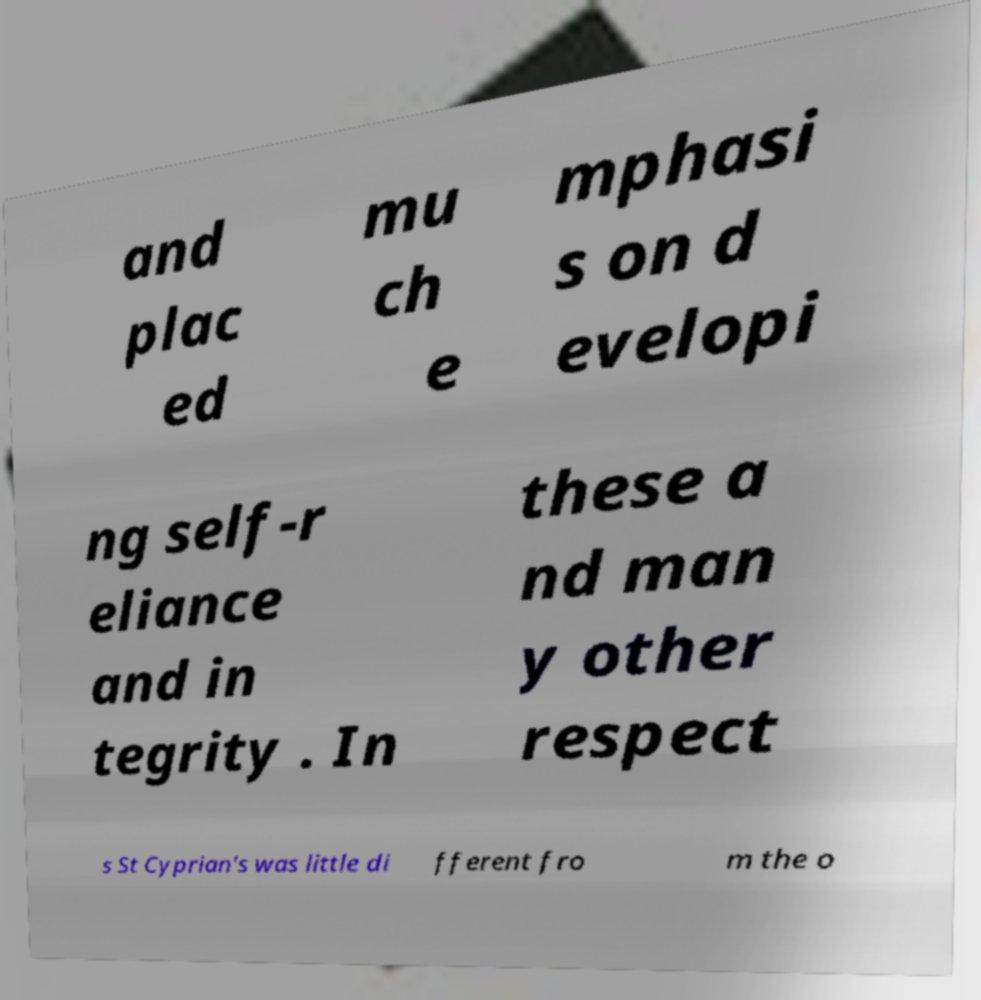Please read and relay the text visible in this image. What does it say? and plac ed mu ch e mphasi s on d evelopi ng self-r eliance and in tegrity . In these a nd man y other respect s St Cyprian's was little di fferent fro m the o 